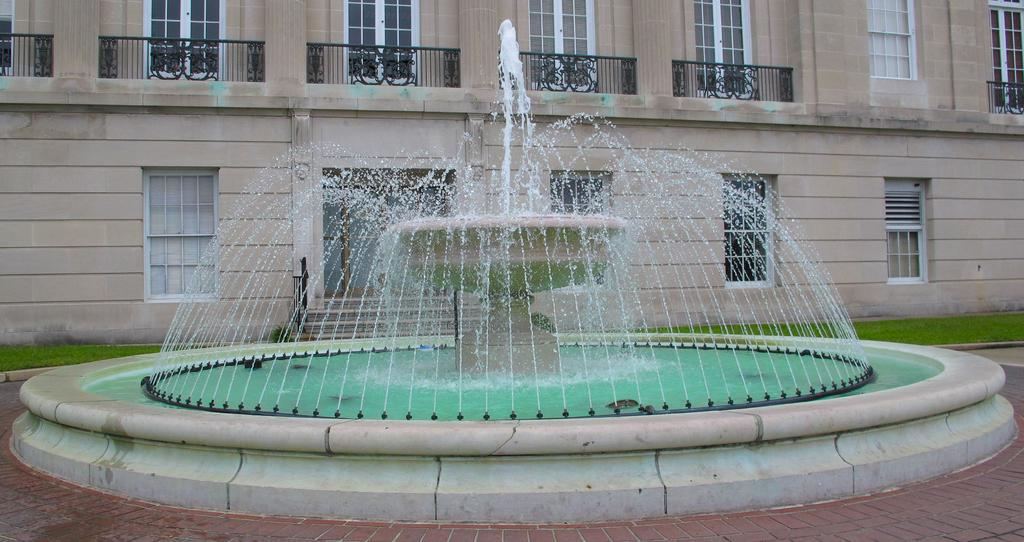What is the main feature in the image? There is a fountain in the image. What can be seen in the distance behind the fountain? There is a building in the background of the image. What architectural elements are visible on the building? There are windows and a grille visible on the building. What type of surface is under the fountain? Grass is present on the ground. What type of voice can be heard coming from the fountain in the image? There is no voice coming from the fountain in the image; it is a visual feature without any audible component. 